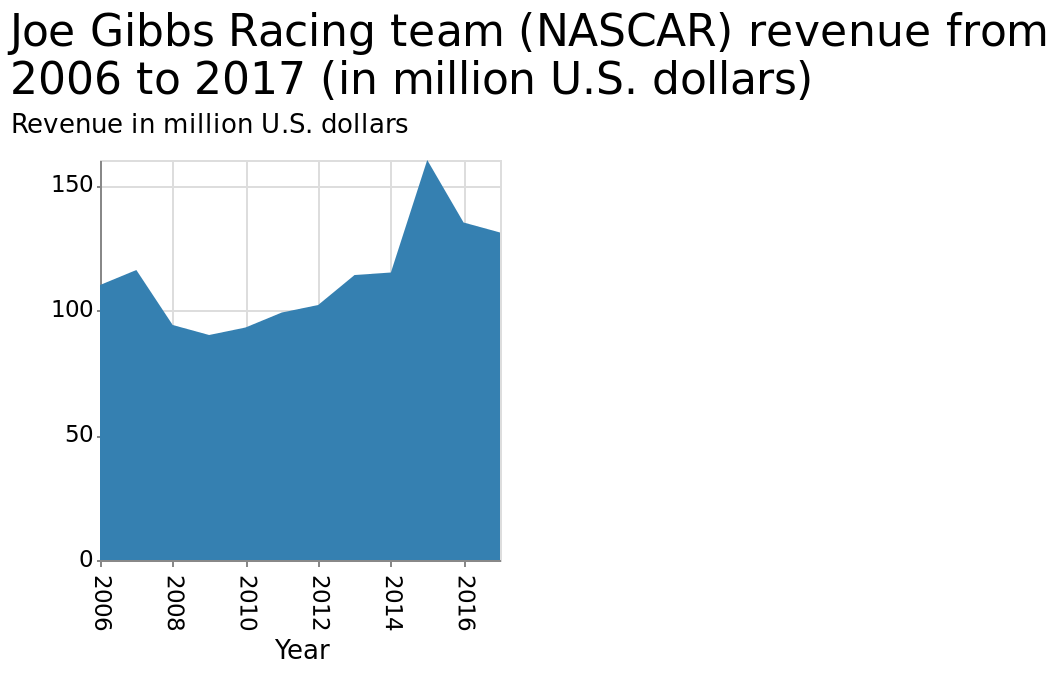<image>
When did NASCAR revenue reach its peak? NASCAR revenue reached its peak in 2015. 